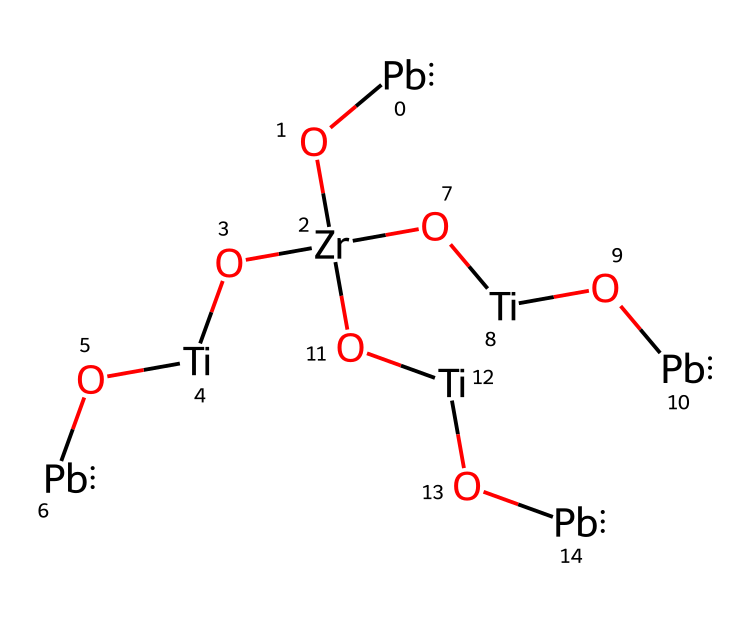What is the main component of lead zirconate titanate? The main components in lead zirconate titanate are lead (Pb), zirconium (Zr), and titanium (Ti), which can be identified from the SMILES representation.
Answer: lead zirconate titanate How many lead atoms are present in the structure? By analyzing the SMILES representation, there are three instances of the symbol [Pb], indicating the presence of three lead atoms in the structure.
Answer: three What type of bonding is expected between Pb, Zr, and Ti? The chemical structure suggests a coordination type bonding between these atoms due to their metallic nature and tendency to form oxides and ceramics, characteristic of bond formation in PZT.
Answer: coordination How does the presence of titanium influence the properties of PZT? Titanium contributes to the ferroelectric properties of the material by being part of the crystal lattice, allowing for domain switching which enhances piezoelectric effects.
Answer: ferroelectric What is the total number of different types of atoms in the PZT structure? By counting the unique elements in the structure, we find lead (Pb), zirconium (Zr), titanium (Ti), and oxygen (O), leading to a total of four different types of atoms present.
Answer: four How does the chemical composition affect the piezoelectric properties? The specific ratio of zirconium to titanium influences the phase stability and the electromechanical coupling coefficient, pivotal for its piezoelectric functionality in sensors.
Answer: electromechanical coupling coefficient 